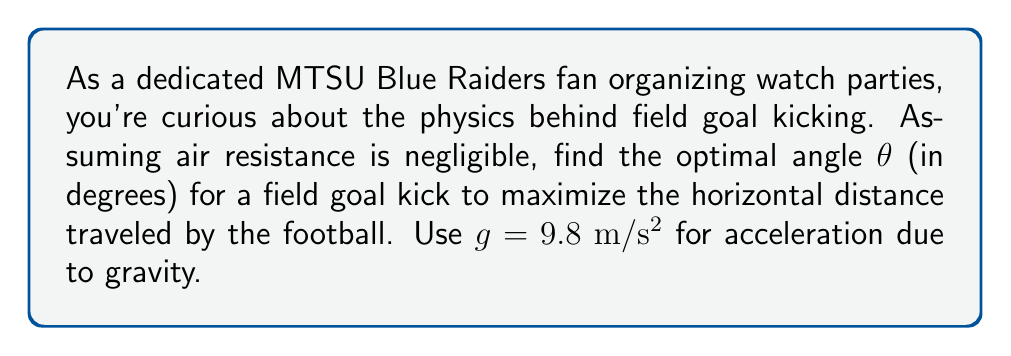Teach me how to tackle this problem. Let's approach this step-by-step:

1) The trajectory of the football follows a parabolic path described by the equations of motion:

   $$x = v_0 \cos(\theta) t$$
   $$y = v_0 \sin(\theta) t - \frac{1}{2}gt^2$$

   Where $v_0$ is the initial velocity, $\theta$ is the launch angle, and $t$ is time.

2) The horizontal distance $R$ is maximized when $y = 0$ (the ball hits the ground). Solving for $t$:

   $$0 = v_0 \sin(\theta) t - \frac{1}{2}gt^2$$
   $$t = \frac{2v_0 \sin(\theta)}{g}$$

3) Substituting this into the equation for $x$:

   $$R = x = v_0 \cos(\theta) \cdot \frac{2v_0 \sin(\theta)}{g} = \frac{2v_0^2 \sin(\theta) \cos(\theta)}{g}$$

4) Using the trigonometric identity $\sin(2\theta) = 2\sin(\theta)\cos(\theta)$, we get:

   $$R = \frac{v_0^2 \sin(2\theta)}{g}$$

5) To find the maximum, we differentiate $R$ with respect to $\theta$ and set it to zero:

   $$\frac{dR}{d\theta} = \frac{v_0^2 \cos(2\theta)}{g} = 0$$

6) This is true when $\cos(2\theta) = 0$, which occurs when $2\theta = 90°$ or $\theta = 45°$.

7) The second derivative is negative at $\theta = 45°$, confirming this is a maximum.

Therefore, the optimal angle for maximum distance is 45°.
Answer: 45° 